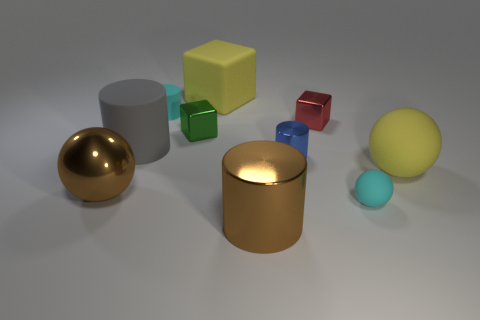Subtract all gray spheres. Subtract all blue cylinders. How many spheres are left? 3 Subtract all spheres. How many objects are left? 7 Add 6 tiny green metal blocks. How many tiny green metal blocks are left? 7 Add 6 tiny cyan matte things. How many tiny cyan matte things exist? 8 Subtract 0 purple cylinders. How many objects are left? 10 Subtract all big purple metallic cylinders. Subtract all matte cubes. How many objects are left? 9 